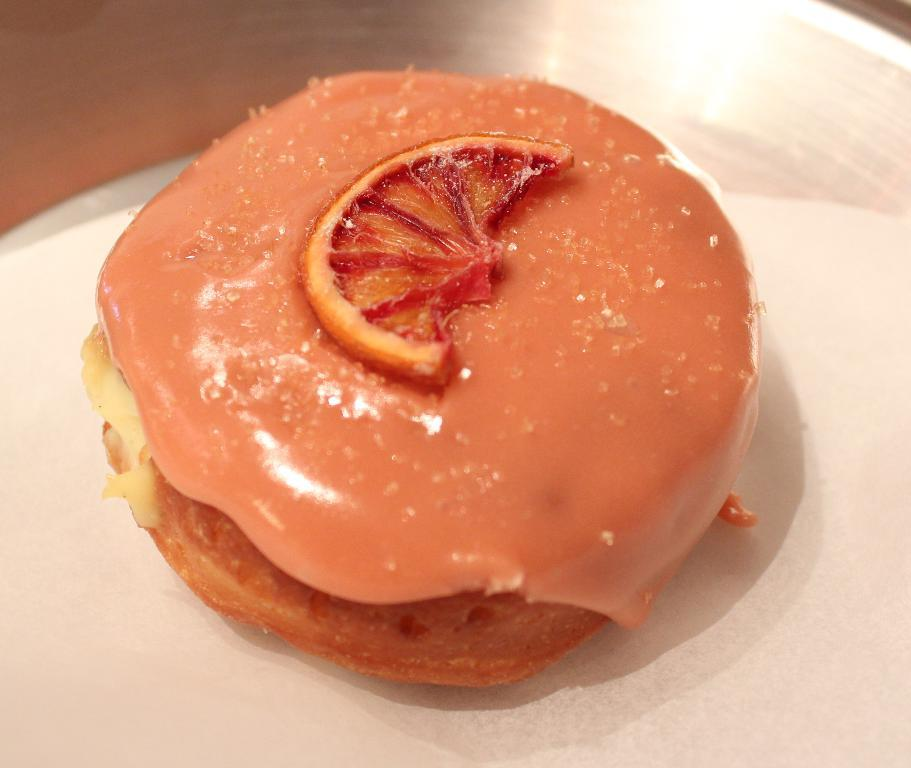What is present on the table in the image? There is a plate on the table in the image. What is the purpose of the plate? The plate is used to hold food items. What can be seen on the plate? There are food items on the plate, and they are in orange color. How many eyes can be seen on the plate in the image? There are no eyes present on the plate in the image. What type of balloon is floating above the plate in the image? There is no balloon present in the image. 